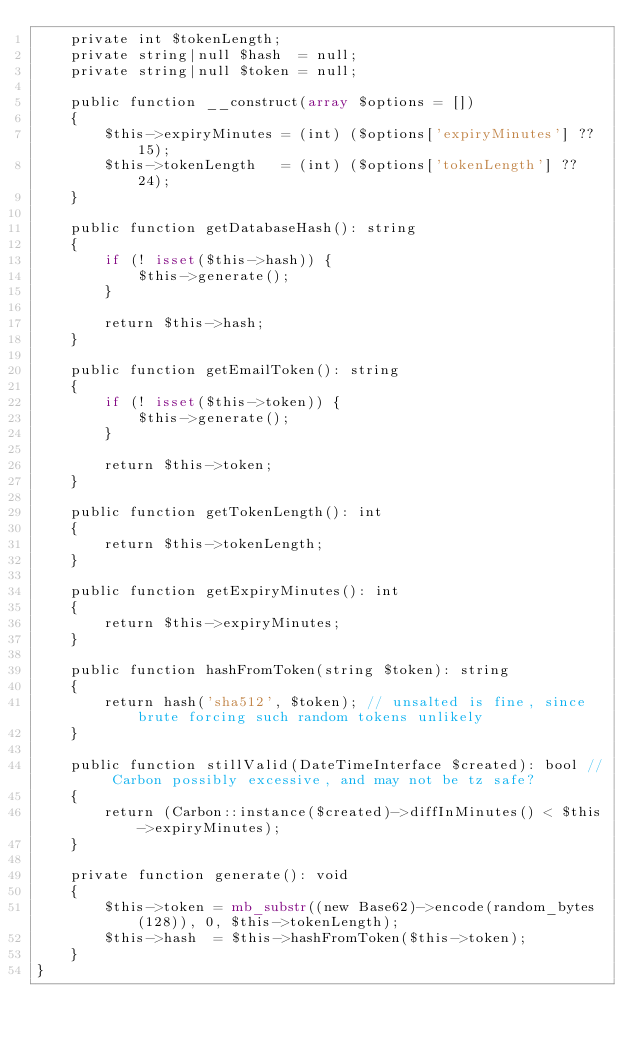<code> <loc_0><loc_0><loc_500><loc_500><_PHP_>    private int $tokenLength;
    private string|null $hash  = null;
    private string|null $token = null;

    public function __construct(array $options = [])
    {
        $this->expiryMinutes = (int) ($options['expiryMinutes'] ?? 15);
        $this->tokenLength   = (int) ($options['tokenLength'] ?? 24);
    }

    public function getDatabaseHash(): string
    {
        if (! isset($this->hash)) {
            $this->generate();
        }

        return $this->hash;
    }

    public function getEmailToken(): string
    {
        if (! isset($this->token)) {
            $this->generate();
        }

        return $this->token;
    }

    public function getTokenLength(): int
    {
        return $this->tokenLength;
    }

    public function getExpiryMinutes(): int
    {
        return $this->expiryMinutes;
    }

    public function hashFromToken(string $token): string
    {
        return hash('sha512', $token); // unsalted is fine, since brute forcing such random tokens unlikely
    }

    public function stillValid(DateTimeInterface $created): bool // Carbon possibly excessive, and may not be tz safe?
    {
        return (Carbon::instance($created)->diffInMinutes() < $this->expiryMinutes);
    }

    private function generate(): void
    {
        $this->token = mb_substr((new Base62)->encode(random_bytes(128)), 0, $this->tokenLength);
        $this->hash  = $this->hashFromToken($this->token);
    }
}
</code> 